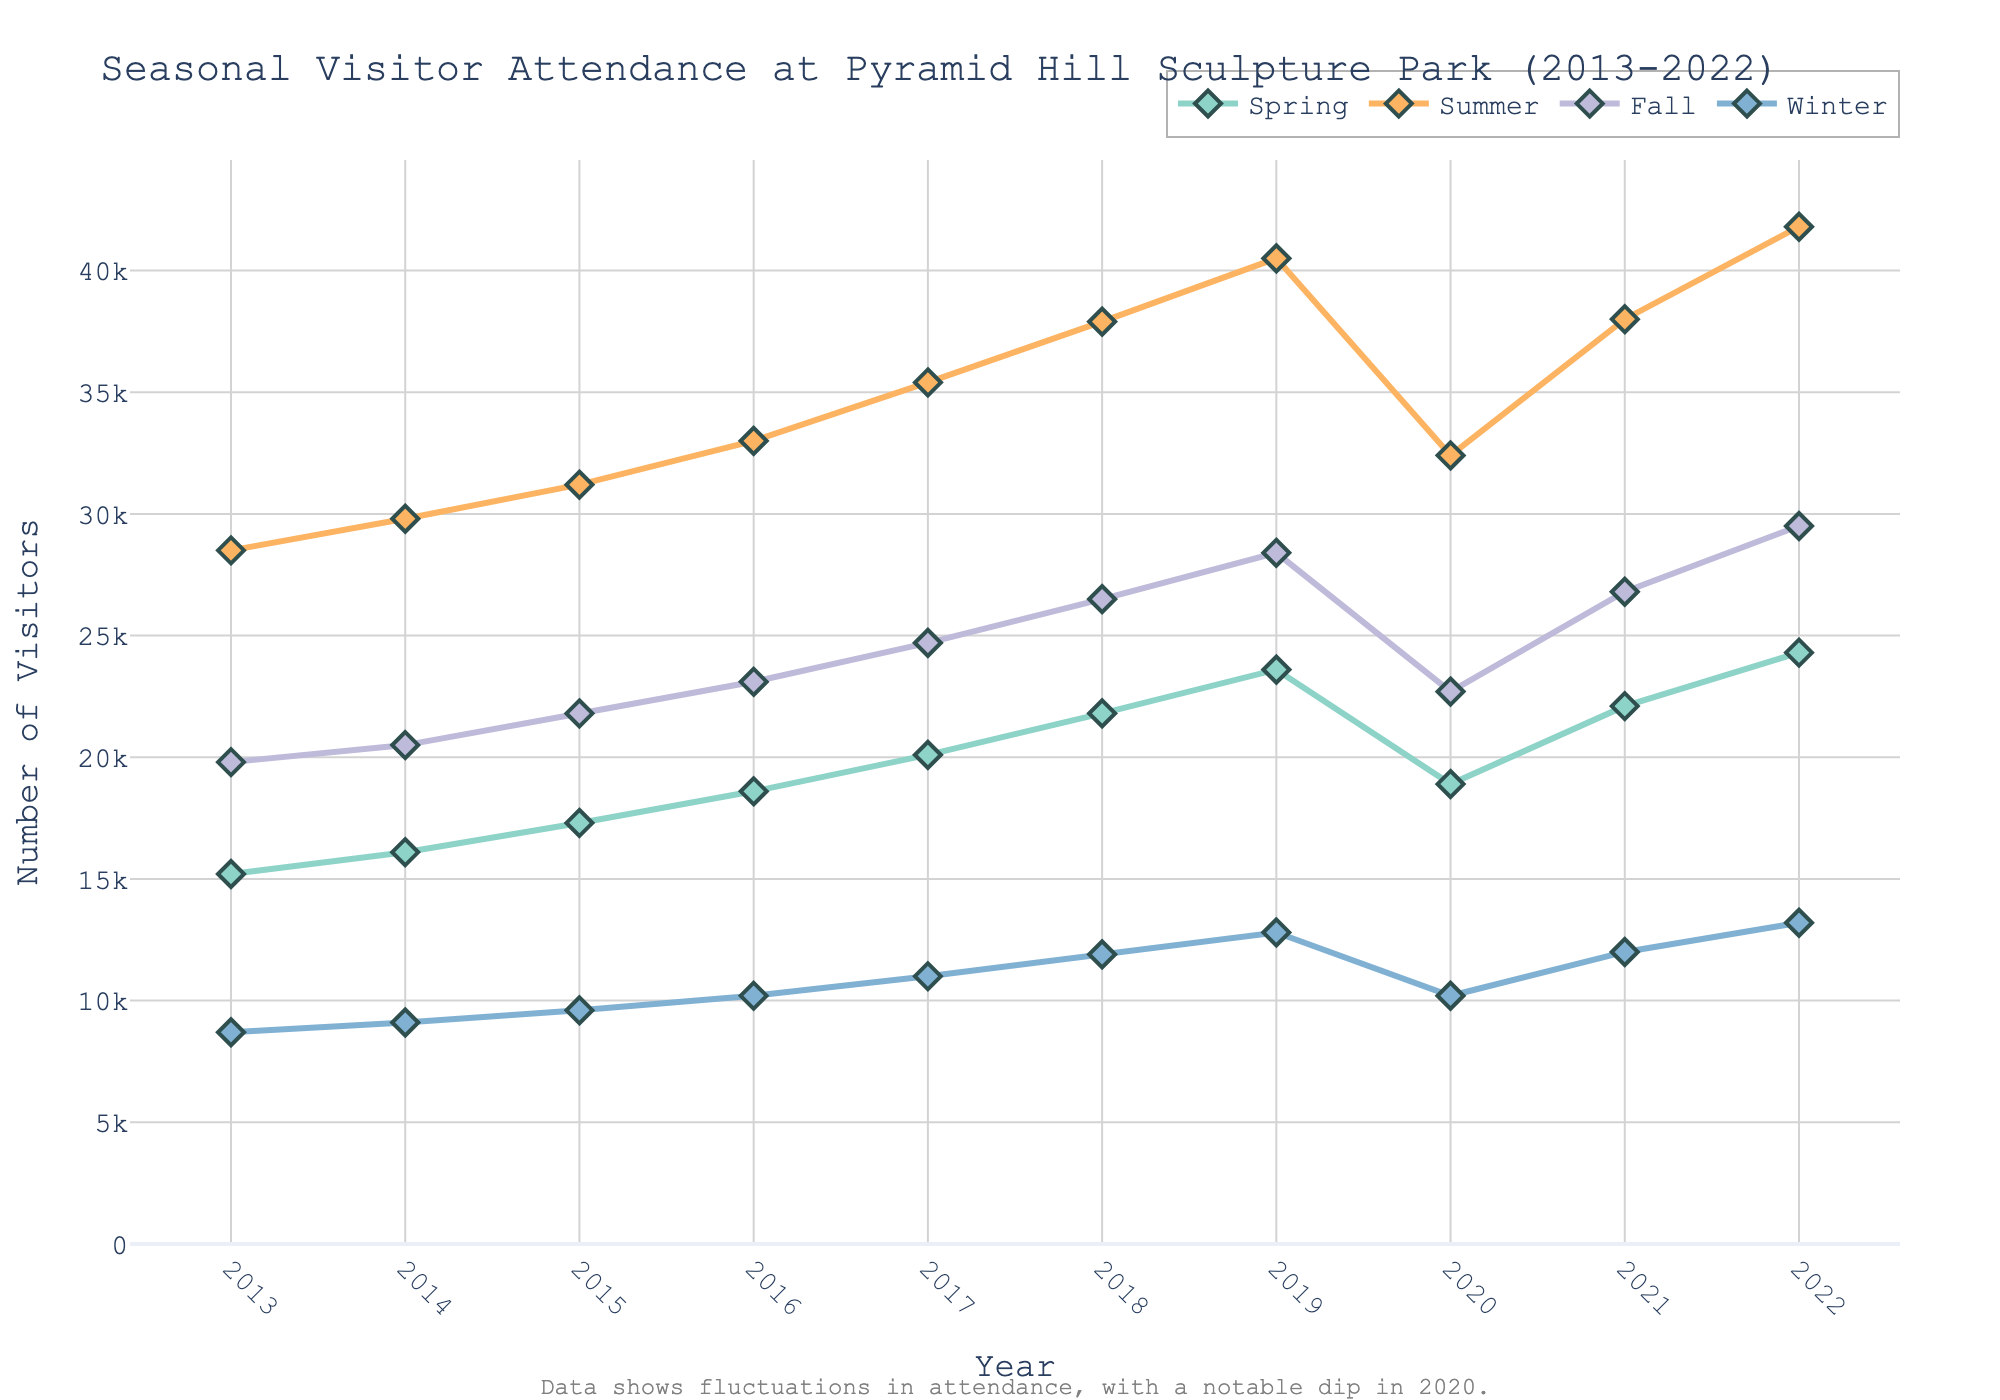what's the year with the highest number of visitors in the summer? To determine the year with the highest summer attendance, we should look at the summer line (orange line) and find its peak. The peak is at 2022 with 41,800 visitors.
Answer: 2022 How did the number of visitors in the winter change from 2019 to 2020? To compare the change in winter attendance between 2019 and 2020, check the values for those years. In 2019, the winter visitors were 12,800, and in 2020, they were 10,200. Subtract the 2020 value from the 2019 value to find the difference: 12,800 - 10,200 = 2,600.
Answer: Decreased by 2,600 What's the average number of visitors in the spring between 2013 and 2018? To find the average, add up the spring visitor numbers from 2013 to 2018 and divide by the total number of years. (15,200 + 16,100 + 17,300 + 18,600 + 20,100 + 21,800) / 6 = 109,100 / 6 = 18,183.33.
Answer: 18,183.33 Which season had the most consistent growth in visitor numbers over the decade? Consistency in growth can be determined by checking the trends in the lines of each season. The summer line (orange) shows a steady and consistent increase each year except for the dip in 2020.
Answer: Summer Compare the number of visitors in the fall of 2020 to the fall of 2021. To compare fall attendance between 2020 and 2021, look at the fall values for those years. For 2020, there were 22,700 visitors, and for 2021, there were 26,800 visitors.
Answer: Higher in 2021 How much did the total number of visitors change from the first year to the last year in the dataset for the spring season? Sum the spring visitors in 2013 (15,200) and 2022 (24,300), then calculate the difference: 24,300 - 15,200 = 9,100.
Answer: Increased by 9,100 In which year did the summer attendance experience a noticeable decrease? Check the summer line (orange) for any noticeable dips. The year 2020 shows a noticeable decrease.
Answer: 2020 What's the combined visitor count for all seasons in the year 2017? Add up the visitor numbers for each season in 2017: 20,100 (spring) + 35,400 (summer) + 24,700 (fall) + 11,000 (winter) = 91,200.
Answer: 91,200 